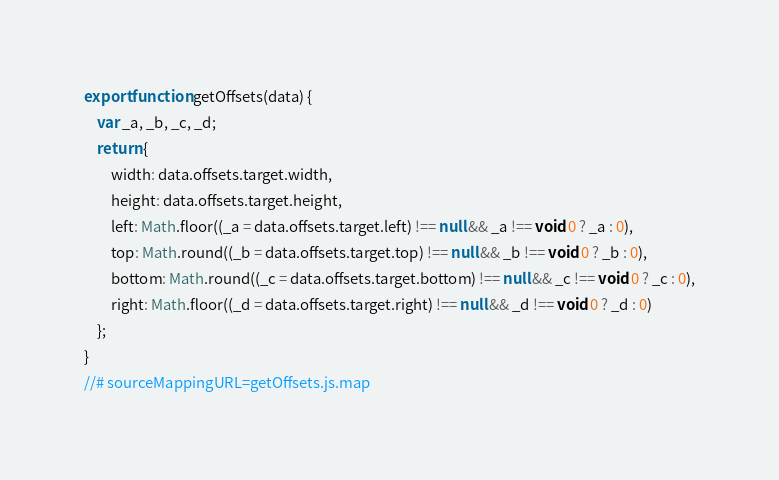<code> <loc_0><loc_0><loc_500><loc_500><_JavaScript_>export function getOffsets(data) {
    var _a, _b, _c, _d;
    return {
        width: data.offsets.target.width,
        height: data.offsets.target.height,
        left: Math.floor((_a = data.offsets.target.left) !== null && _a !== void 0 ? _a : 0),
        top: Math.round((_b = data.offsets.target.top) !== null && _b !== void 0 ? _b : 0),
        bottom: Math.round((_c = data.offsets.target.bottom) !== null && _c !== void 0 ? _c : 0),
        right: Math.floor((_d = data.offsets.target.right) !== null && _d !== void 0 ? _d : 0)
    };
}
//# sourceMappingURL=getOffsets.js.map</code> 